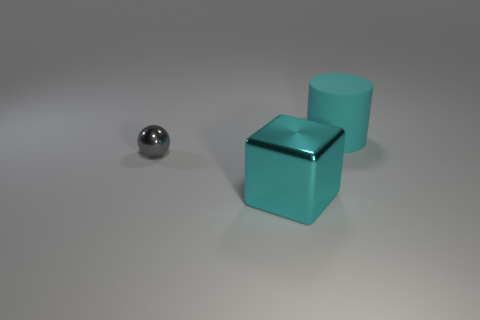Add 2 large red metallic cubes. How many objects exist? 5 Subtract all spheres. How many objects are left? 2 Add 1 spheres. How many spheres exist? 2 Subtract 0 yellow balls. How many objects are left? 3 Subtract all big cyan metal objects. Subtract all spheres. How many objects are left? 1 Add 3 metallic things. How many metallic things are left? 5 